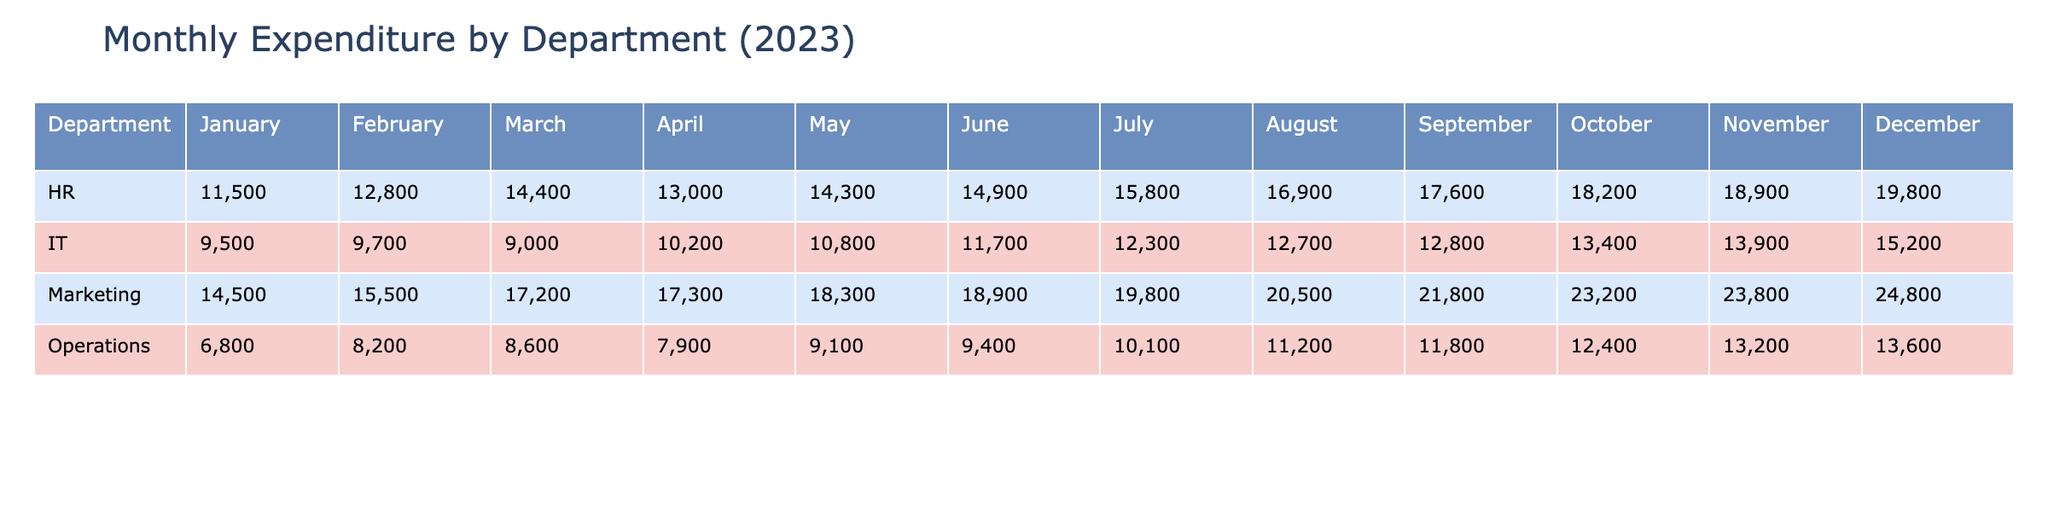What was the actual expenditure for the IT department in June? The table shows that for the IT department in June, the actual expenditure is listed directly under June in the IT row. The value is 11,700.
Answer: 11,700 Which department had the highest projected expenditure in October? In October, the marketing department's projected expenditure is listed as the highest among all departments, which is 23,000.
Answer: Marketing What is the variance for the HR department in March? By looking at the HR row for March, the variance is shown and is calculated as actual expenditure minus projected expenditure. For March, it is 400.
Answer: 400 Did the Operations department go over the projected expenditure in July? To find out, we compare the actual expenditure (10,100) with the projected expenditure (10,000) for the Operations department in July. Since the actual is greater than the projected, they went over.
Answer: Yes What was the total actual expenditure for the Marketing department from January to March? We sum the values for the Marketing department from the table for January (14,500), February (15,500), and March (17,200). The total is 14,500 + 15,500 + 17,200 = 47,200.
Answer: 47,200 Which month had the highest actual expenditure for the HR department? By reviewing the HR department row, we observe the values for each month. The highest value is in March, where the actual expenditure is 14,400.
Answer: March What is the average projected expenditure for the IT department across all months? To calculate the average, we first sum the projected expenditures for the IT department over the months: 9,000 + 10,000 + 9,500 + 10,500 + 11,000 + 11,500 + 12,000 + 12,500 + 13,000 + 13,500 + 14,000 + 15,000 = 135,000. Then divide by 12 months, giving us 135,000 / 12 = 11,250.
Answer: 11,250 Was the actual expenditure for the Operations department ever lower than the projected expenditure in November? The table shows that for November, the projected expenditure for Operations is 13,000, and the actual expenditure is 13,200. Thus, the actual exceeds the projected, which means it was not lower.
Answer: No In which month did the Marketing department achieve its highest variance? The variance can be determined by comparing all months for the Marketing department. The highest variance is in May, where it is 300 (actual exceeded projected).
Answer: May What was the difference between projected and actual expenditure for the HR department in December? In December, the projected expenditure for HR is 20,000 and the actual is 19,800. The difference (variance) is calculated as 20,000 - 19,800, resulting in 200.
Answer: 200 